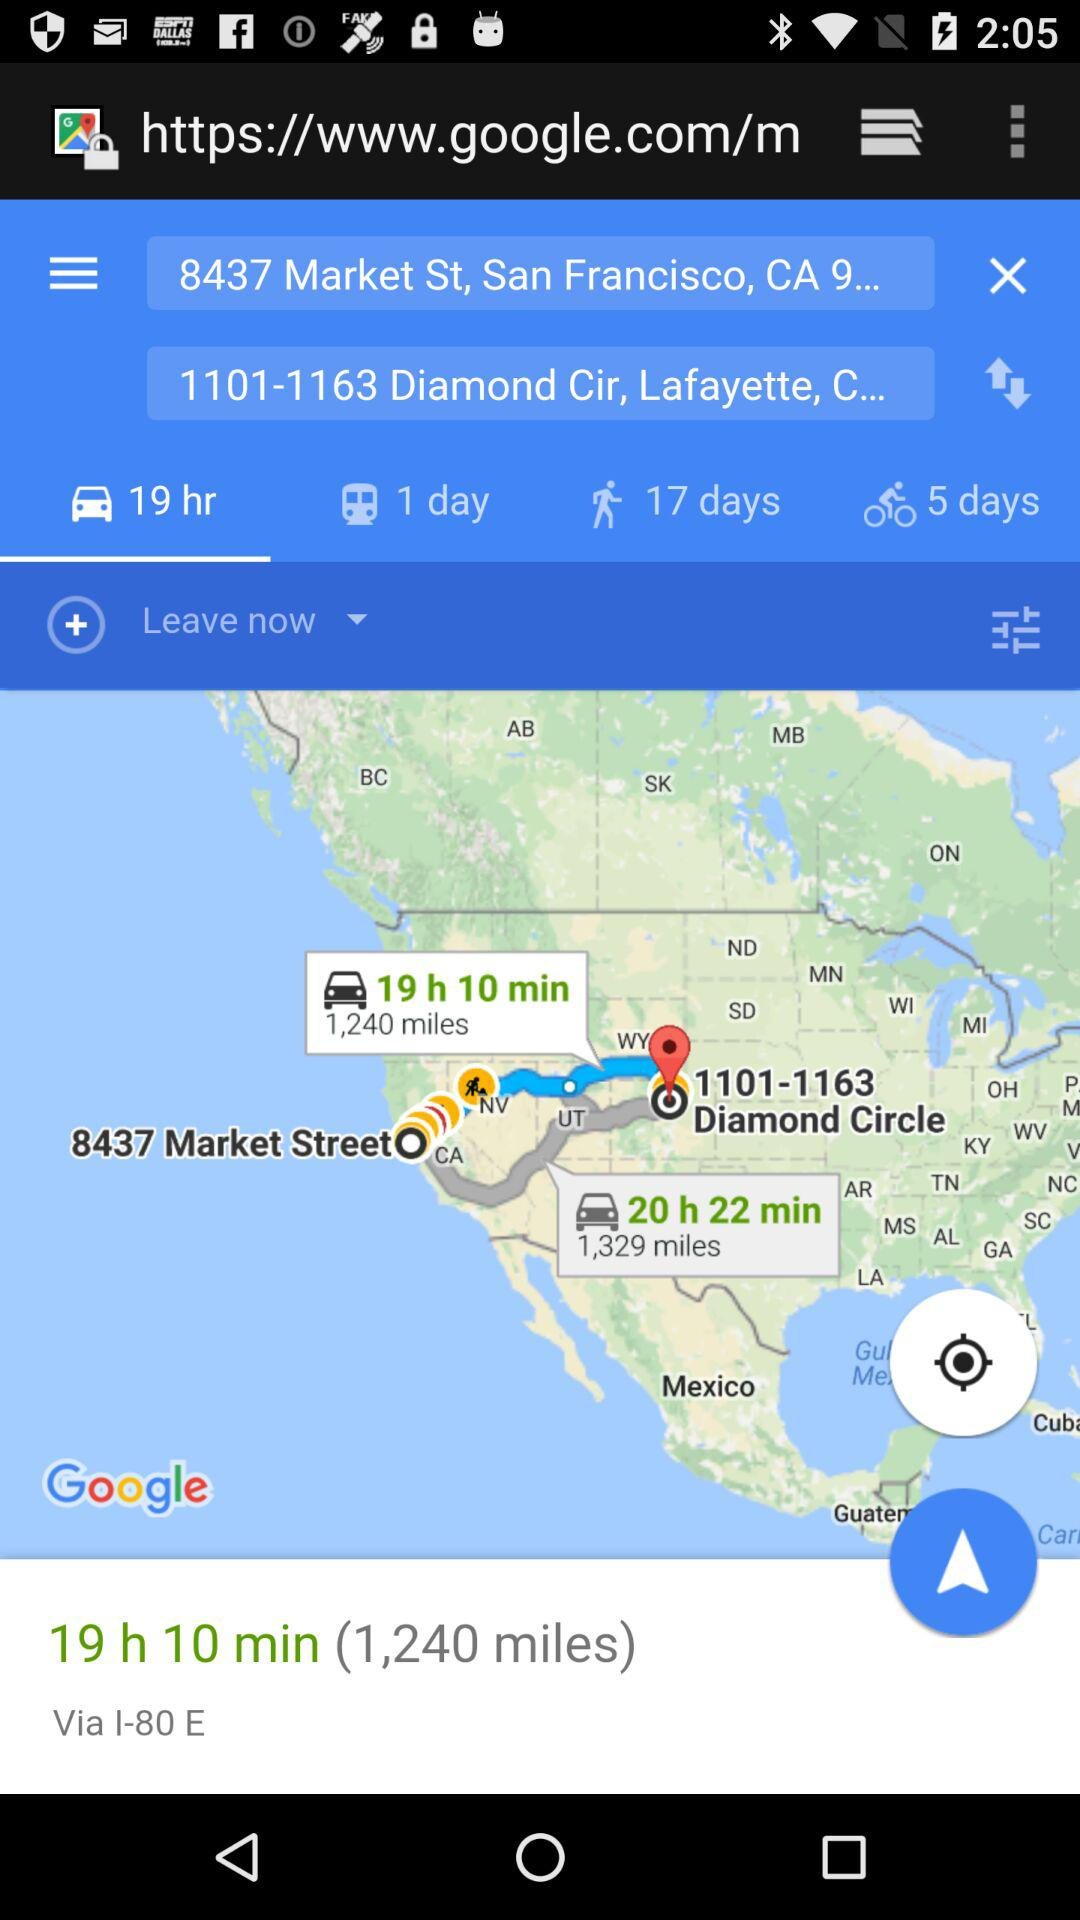What is the distance? The distances are 1,240 miles and 1,329 miles. 